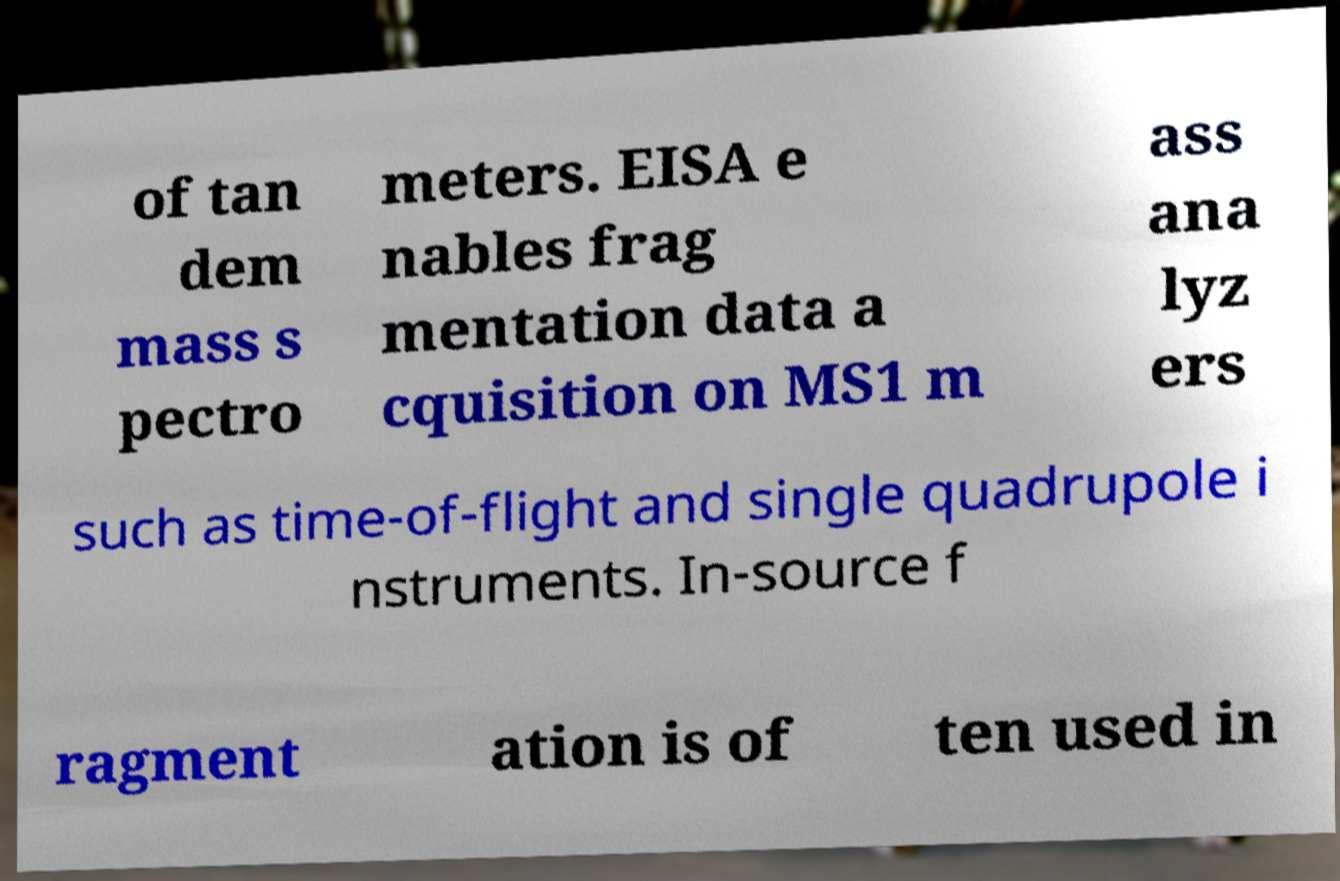I need the written content from this picture converted into text. Can you do that? of tan dem mass s pectro meters. EISA e nables frag mentation data a cquisition on MS1 m ass ana lyz ers such as time-of-flight and single quadrupole i nstruments. In-source f ragment ation is of ten used in 